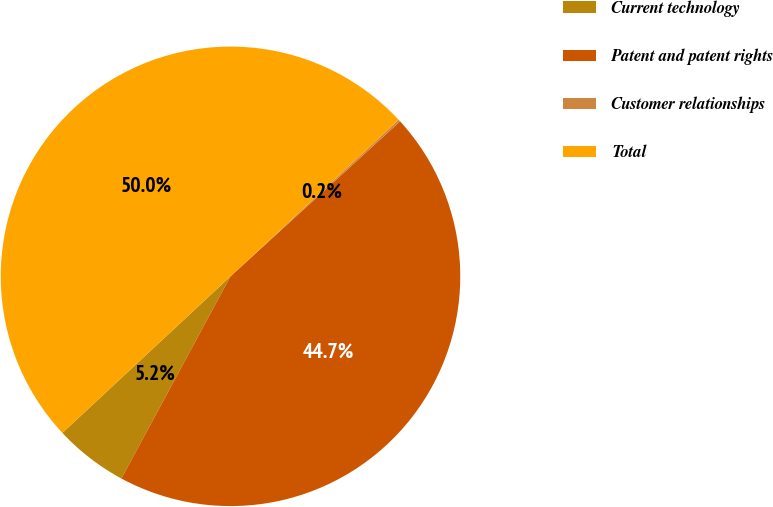Convert chart. <chart><loc_0><loc_0><loc_500><loc_500><pie_chart><fcel>Current technology<fcel>Patent and patent rights<fcel>Customer relationships<fcel>Total<nl><fcel>5.19%<fcel>44.66%<fcel>0.15%<fcel>50.0%<nl></chart> 